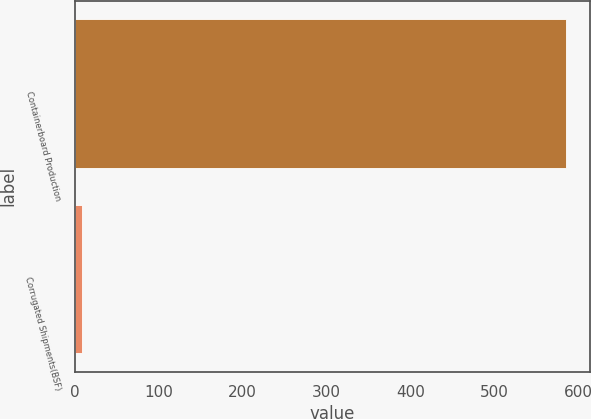Convert chart. <chart><loc_0><loc_0><loc_500><loc_500><bar_chart><fcel>Containerboard Production<fcel>Corrugated Shipments(BSF)<nl><fcel>585<fcel>8<nl></chart> 